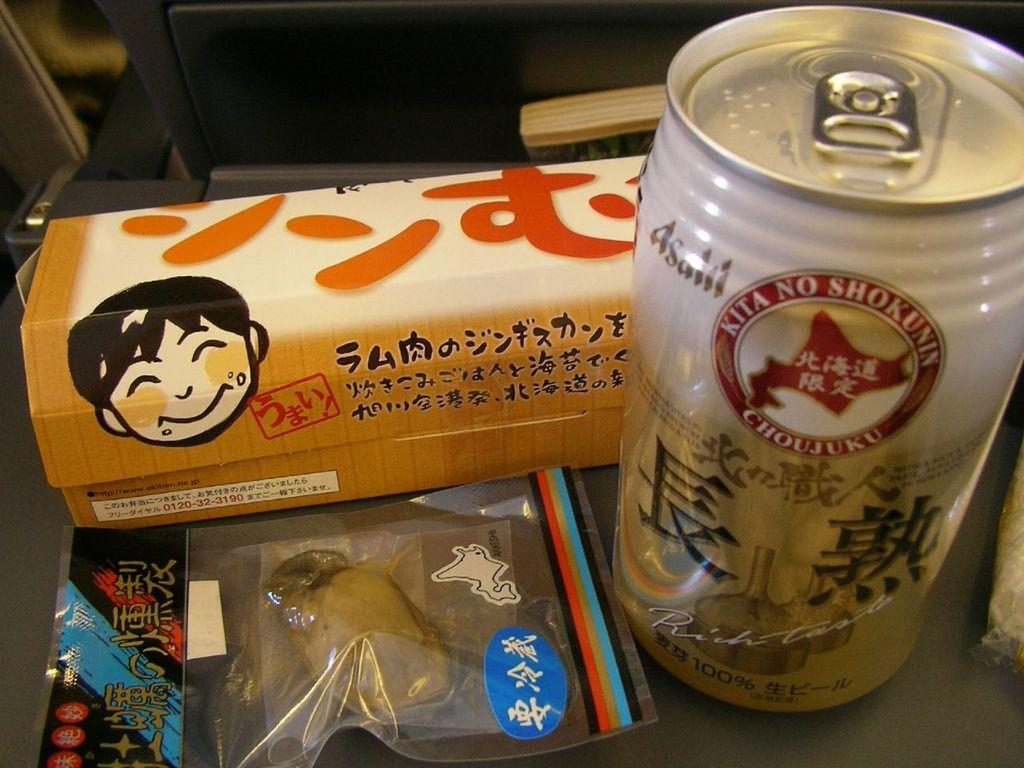<image>
Offer a succinct explanation of the picture presented. A  pair of japanese snacks with a can of kita no shokunin next to them. 